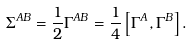Convert formula to latex. <formula><loc_0><loc_0><loc_500><loc_500>\Sigma ^ { A B } = \frac { 1 } { 2 } \Gamma ^ { A B } = \frac { 1 } { 4 } \left [ \Gamma ^ { A } , \Gamma ^ { B } \right ] .</formula> 